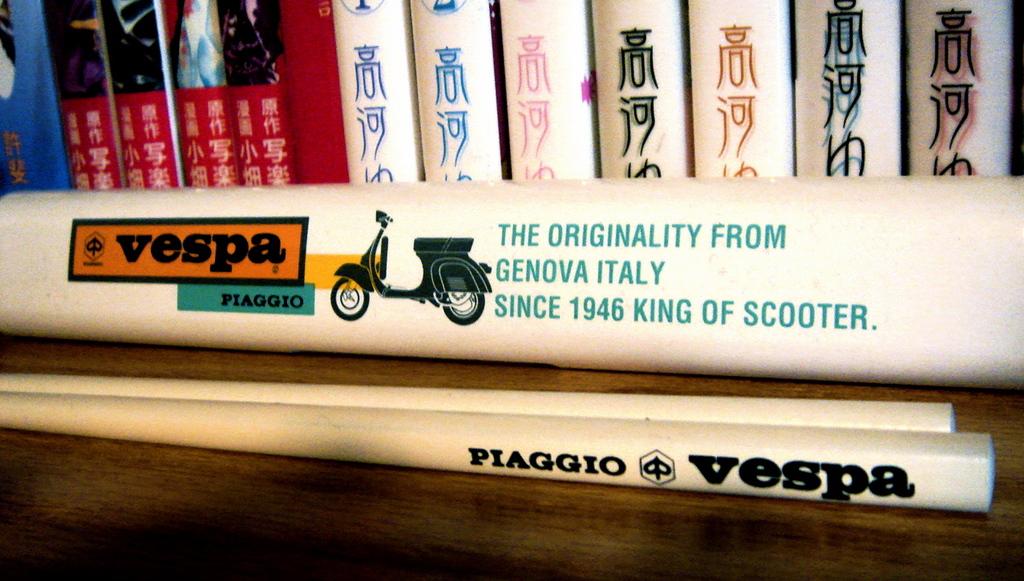Where is the scooter originally from?
Provide a short and direct response. Genova italy. What is the bottom book title?
Provide a short and direct response. Vespa. 